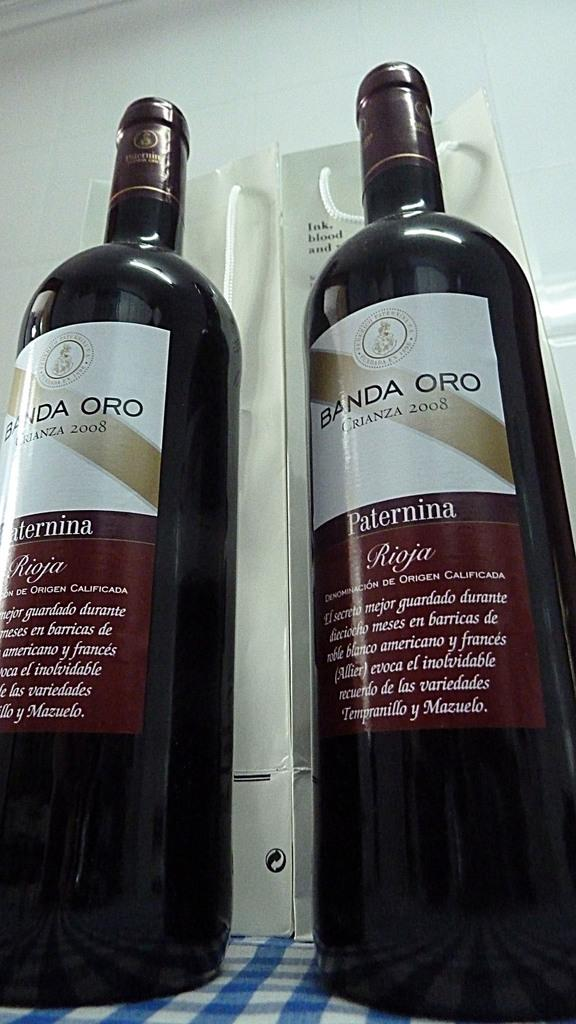Provide a one-sentence caption for the provided image. Two bottles of wine named BANDA ORO Paternina. 